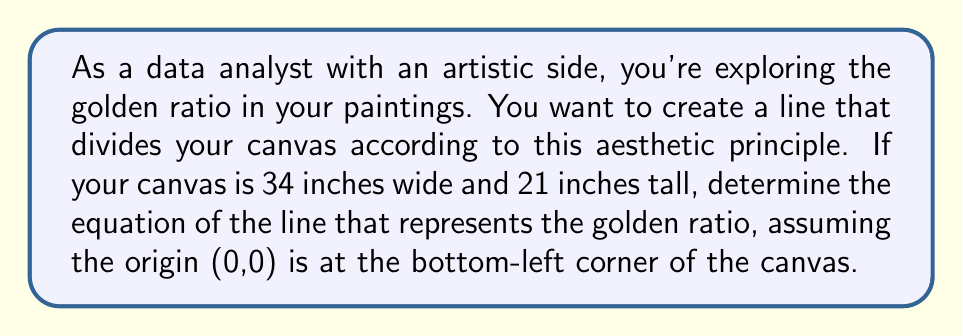Teach me how to tackle this problem. Let's approach this step-by-step:

1) The golden ratio, denoted by φ (phi), is approximately 1.618. In a composition, this means dividing a length into two parts where the ratio of the whole to the larger part is equal to the ratio of the larger part to the smaller part.

2) For our canvas, the width (34 inches) represents the whole, and we need to find the point where it should be divided. Let's call this point x.

3) The golden ratio equation is:
   $$ \frac{34}{x} = \frac{x}{34-x} = φ ≈ 1.618 $$

4) Solving for x:
   $$ x^2 = 34(34-x) $$
   $$ x^2 = 1156 - 34x $$
   $$ x^2 + 34x - 1156 = 0 $$

5) Using the quadratic formula, we get x ≈ 21 inches

6) This means our line should pass through the point (21, 0) and (21, 21)

7) The equation of a vertical line passing through x = 21 is:
   $$ x = 21 $$

8) However, to make it more relevant to our 2D canvas, let's express it in the form y = mx + b:
   $$ y = \infty \cdot (x - 21) $$

   Where ∞ represents an undefined slope for a vertical line.
Answer: $x = 21$ or $y = \infty \cdot (x - 21)$ 